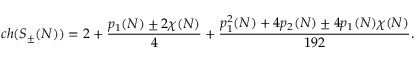<formula> <loc_0><loc_0><loc_500><loc_500>c h ( S _ { \pm } ( N ) ) = 2 + { \frac { p _ { 1 } ( N ) \pm 2 \chi ( N ) } { 4 } } + { \frac { p _ { 1 } ^ { 2 } ( N ) + 4 p _ { 2 } ( N ) \pm 4 p _ { 1 } ( N ) \chi ( N ) } { 1 9 2 } } .</formula> 